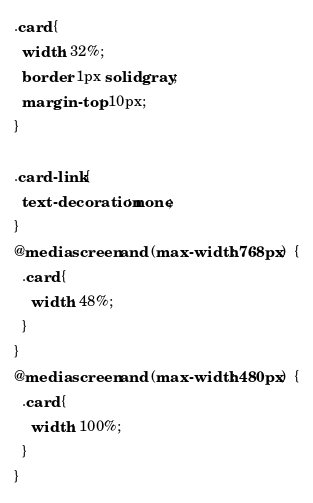<code> <loc_0><loc_0><loc_500><loc_500><_CSS_>
.card {
  width: 32%;
  border: 1px solid gray;
  margin-top: 10px;
}

.card-link {
  text-decoration: none;
}
@media screen and (max-width: 768px)  {
  .card {
    width: 48%;
  }
}
@media screen and (max-width: 480px)  {
  .card {
    width: 100%;
  }
}</code> 